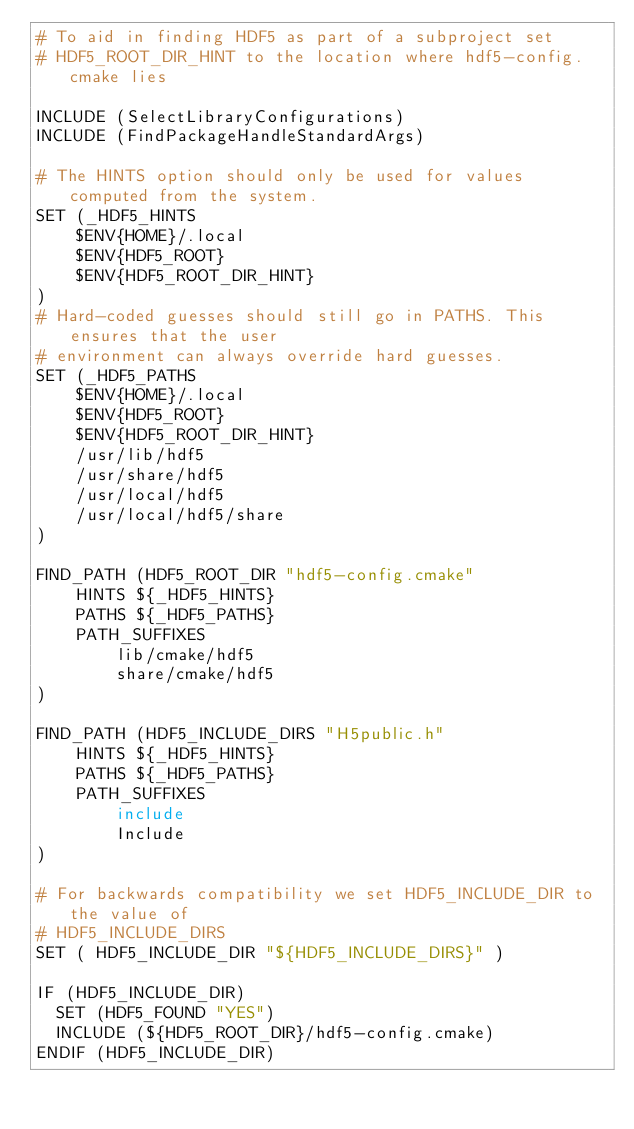Convert code to text. <code><loc_0><loc_0><loc_500><loc_500><_CMake_># To aid in finding HDF5 as part of a subproject set
# HDF5_ROOT_DIR_HINT to the location where hdf5-config.cmake lies

INCLUDE (SelectLibraryConfigurations)
INCLUDE (FindPackageHandleStandardArgs)

# The HINTS option should only be used for values computed from the system.
SET (_HDF5_HINTS
    $ENV{HOME}/.local
    $ENV{HDF5_ROOT}
    $ENV{HDF5_ROOT_DIR_HINT}
)
# Hard-coded guesses should still go in PATHS. This ensures that the user
# environment can always override hard guesses.
SET (_HDF5_PATHS
    $ENV{HOME}/.local
    $ENV{HDF5_ROOT}
    $ENV{HDF5_ROOT_DIR_HINT}
    /usr/lib/hdf5
    /usr/share/hdf5
    /usr/local/hdf5
    /usr/local/hdf5/share
)

FIND_PATH (HDF5_ROOT_DIR "hdf5-config.cmake"
    HINTS ${_HDF5_HINTS}
    PATHS ${_HDF5_PATHS}
    PATH_SUFFIXES
        lib/cmake/hdf5
        share/cmake/hdf5
)

FIND_PATH (HDF5_INCLUDE_DIRS "H5public.h"
    HINTS ${_HDF5_HINTS}
    PATHS ${_HDF5_PATHS}
    PATH_SUFFIXES
        include
        Include
)

# For backwards compatibility we set HDF5_INCLUDE_DIR to the value of
# HDF5_INCLUDE_DIRS
SET ( HDF5_INCLUDE_DIR "${HDF5_INCLUDE_DIRS}" )

IF (HDF5_INCLUDE_DIR)
  SET (HDF5_FOUND "YES")
  INCLUDE (${HDF5_ROOT_DIR}/hdf5-config.cmake)
ENDIF (HDF5_INCLUDE_DIR)
</code> 